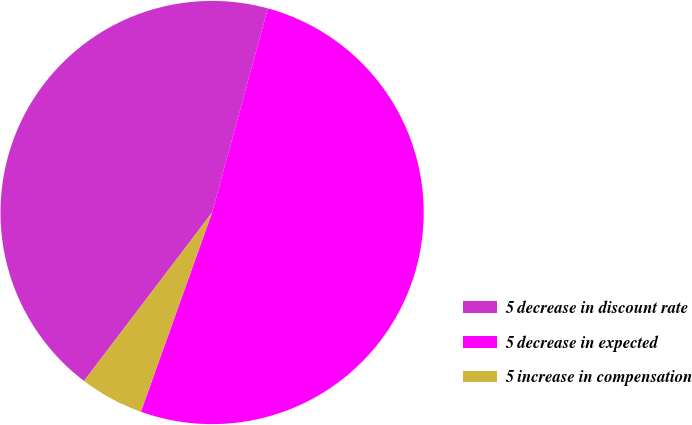Convert chart. <chart><loc_0><loc_0><loc_500><loc_500><pie_chart><fcel>5 decrease in discount rate<fcel>5 decrease in expected<fcel>5 increase in compensation<nl><fcel>43.9%<fcel>51.22%<fcel>4.88%<nl></chart> 